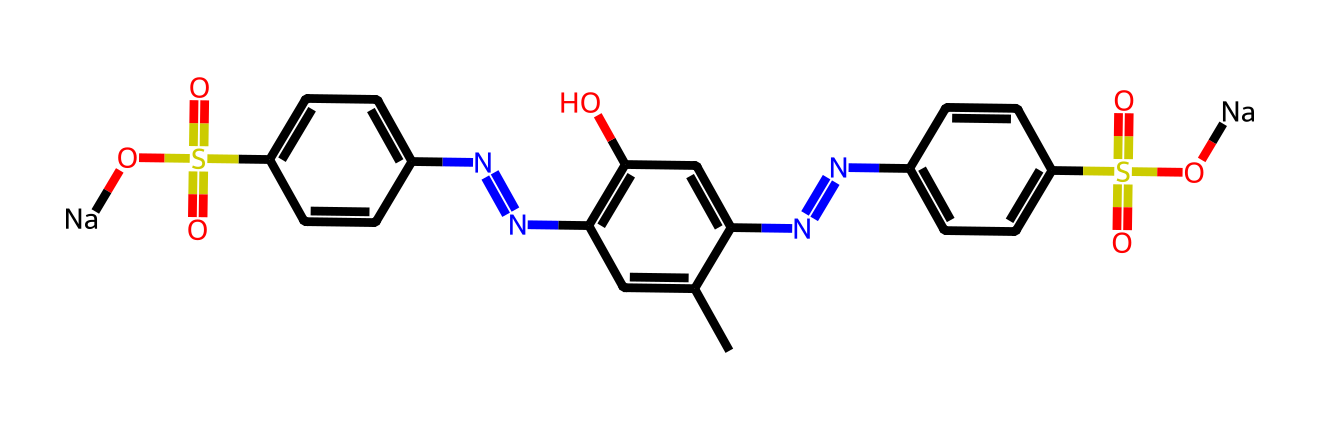What is the main functional group present in the chemical? The SMILES representation shows a sulfonic acid group (S(=O)(=O)O) in the structure, indicating a sulfonate functional group.
Answer: sulfonate How many nitrogen atoms are present in the chemical? By analyzing the SMILES, we can count three nitrogen atoms (N) within the structure, each indicated in separate positions.
Answer: three Are there any sodium atoms in this chemical structure? The SMILES representation includes two instances of [Na], indicating the presence of two sodium atoms in the molecule.
Answer: two What type of bonds are mainly present between the carbon atoms in this structure? The bonds between carbon atoms are primarily represented as double bonds (C=C) and single bonds (C-C), which are typical of aromatic compounds.
Answer: double and single Which part of this chemical structure contributes to its color? The aromatic rings and conjugated double bonds allow for the absorption of visible light, which is characteristic of many colored compounds.
Answer: aromatic rings What is the total number of ring structures present in the chemical? Upon examining the structure, there are three distinct ring systems formed in the chemical, which can be identified by the cyclic components in the SMILES notation.
Answer: three 